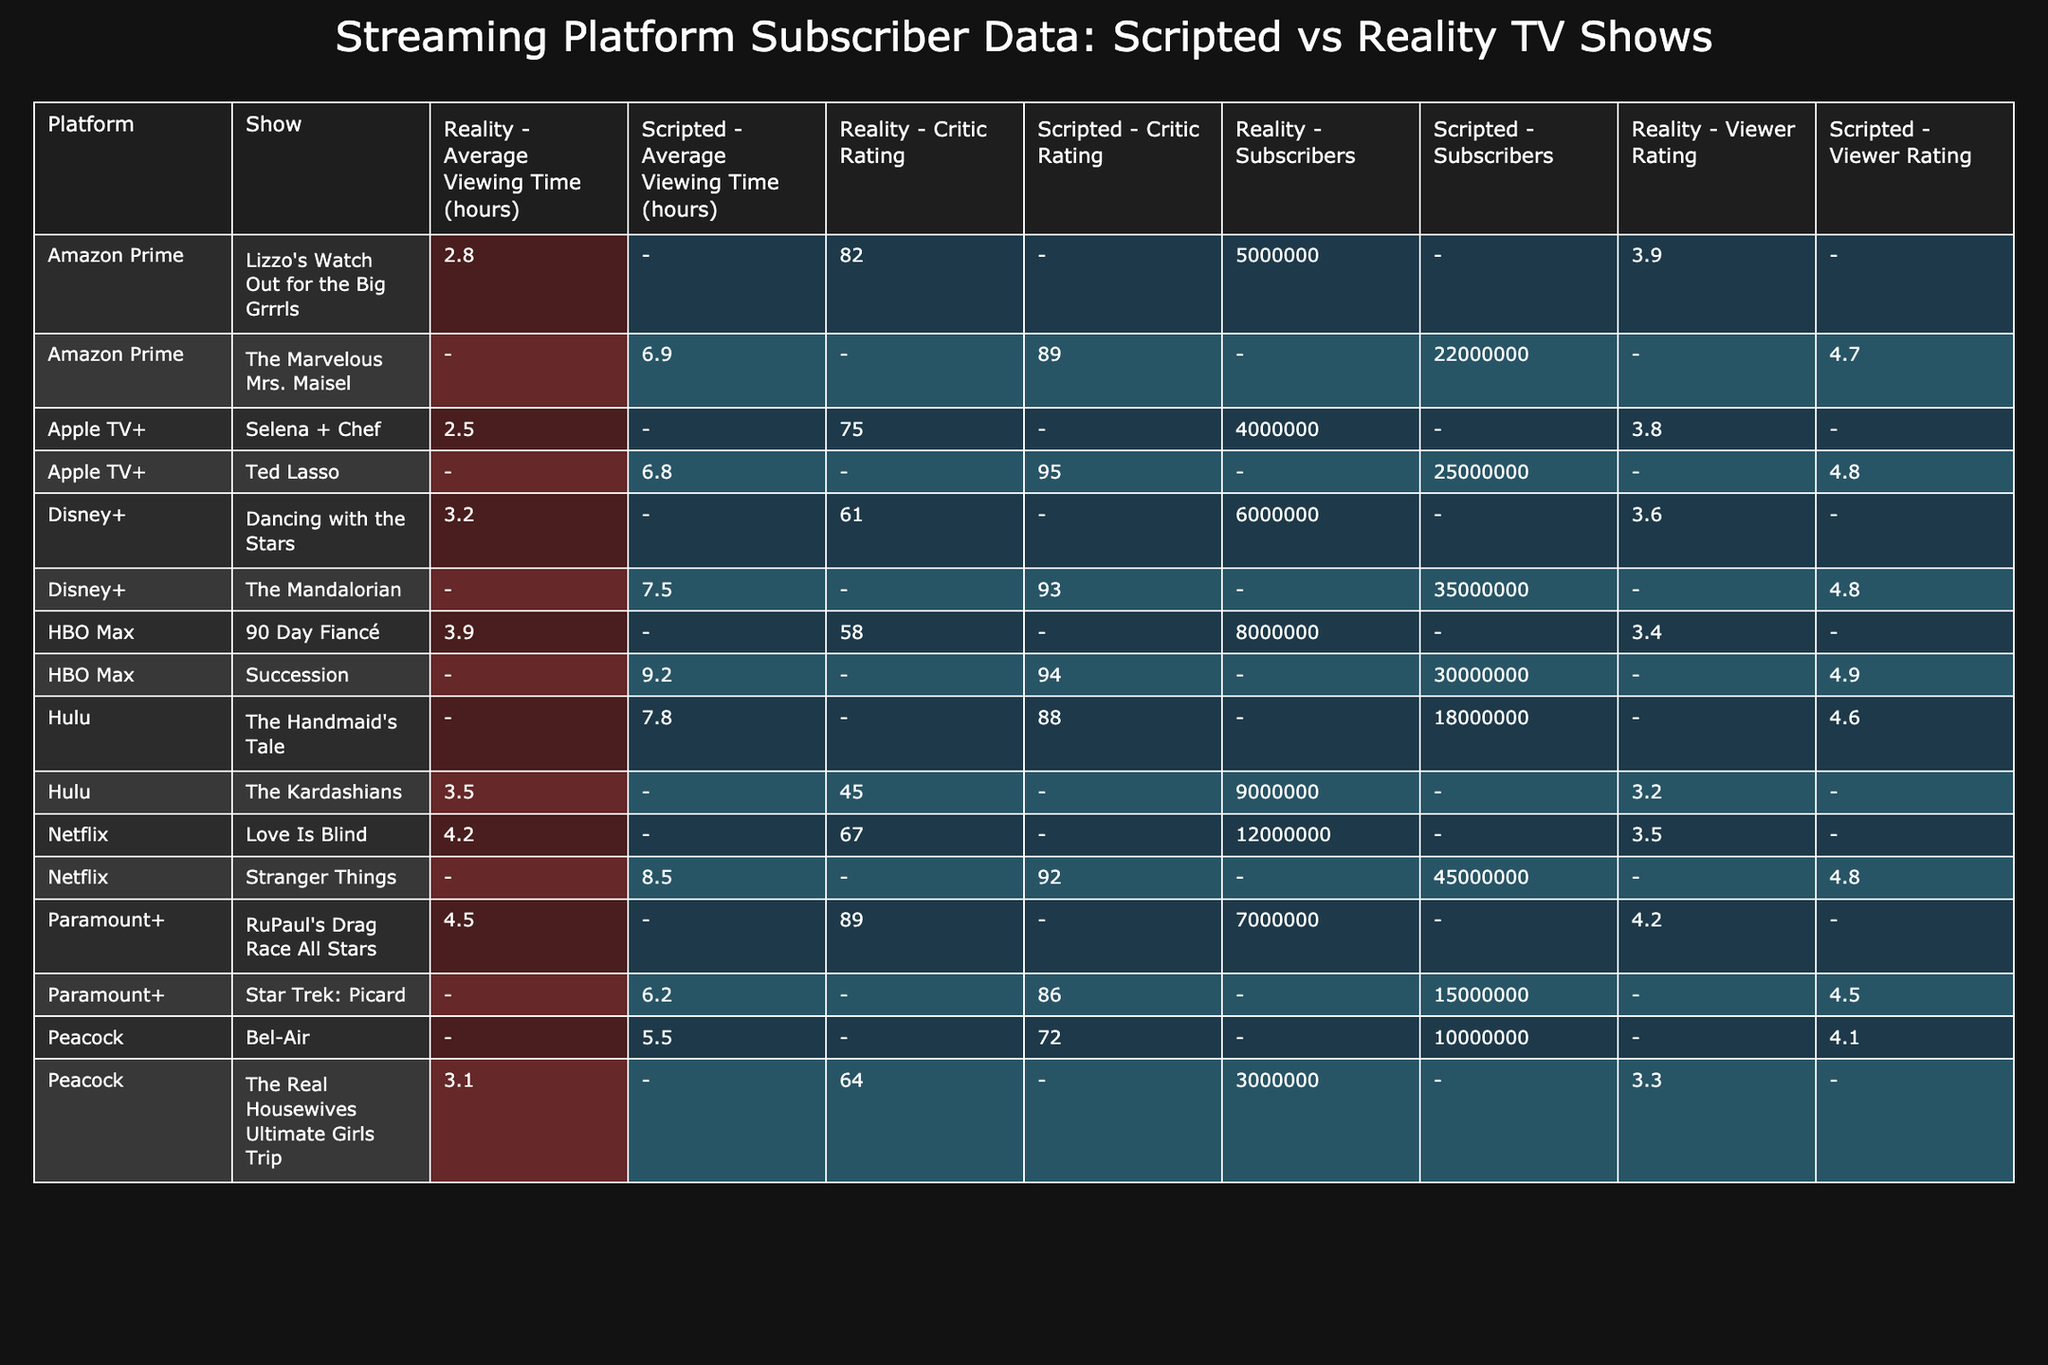What is the total number of subscribers for scripted TV shows? To find the total subscribers for scripted TV shows, I need to add the subscriber counts for all scripted shows: 45,000,000 (Stranger Things) + 18,000,000 (The Handmaid's Tale) + 22,000,000 (The Marvelous Mrs. Maisel) + 30,000,000 (Succession) + 35,000,000 (The Mandalorian) + 25,000,000 (Ted Lasso) + 10,000,000 (Bel-Air) + 15,000,000 (Star Trek: Picard) = 255,000,000.
Answer: 255,000,000 Which reality TV show has the highest number of subscribers? I will compare the subscriber counts for each reality show. The counts are: 12,000,000 (Love Is Blind), 9,000,000 (The Kardashians), 5,000,000 (Lizzo's Watch Out for the Big Grrrls), 8,000,000 (90 Day Fiancé), 6,000,000 (Dancing with the Stars), 4,000,000 (Selena + Chef), 3,000,000 (The Real Housewives Ultimate Girls Trip), and 7,000,000 (RuPaul's Drag Race All Stars). The highest is 12,000,000 for Love Is Blind.
Answer: Love Is Blind What is the average viewing time for scripted shows? To find the average viewing time, add the viewing times for all scripted shows and divide by the number of scripted shows. The viewing times are: 8.5 (Stranger Things) + 7.8 (The Handmaid's Tale) + 6.9 (The Marvelous Mrs. Maisel) + 9.2 (Succession) + 7.5 (The Mandalorian) + 6.8 (Ted Lasso) + 5.5 (Bel-Air) + 6.2 (Star Trek: Picard). There are 8 shows, so the average is (8.5 + 7.8 + 6.9 + 9.2 + 7.5 + 6.8 + 5.5 + 6.2) / 8 = 7.5.
Answer: 7.5 Is the viewer rating for all reality shows below 5? I need to check the viewer ratings for each reality show: 3.5 (Love Is Blind), 3.2 (The Kardashians), 3.9 (Lizzo's Watch Out for the Big Grrrls), 3.4 (90 Day Fiancé), 3.6 (Dancing with the Stars), 3.8 (Selena + Chef), 3.3 (The Real Housewives Ultimate Girls Trip), and 4.2 (RuPaul's Drag Race All Stars). Since 4.2 is above 5, not all viewer ratings are below 5, so the answer is false.
Answer: False What is the difference in subscriber numbers between the highest scripted and the highest reality show? The highest scripted show is Stranger Things with 45,000,000 subscribers. The highest reality show is Love Is Blind with 12,000,000 subscribers. The difference is 45,000,000 - 12,000,000 = 33,000,000.
Answer: 33,000,000 